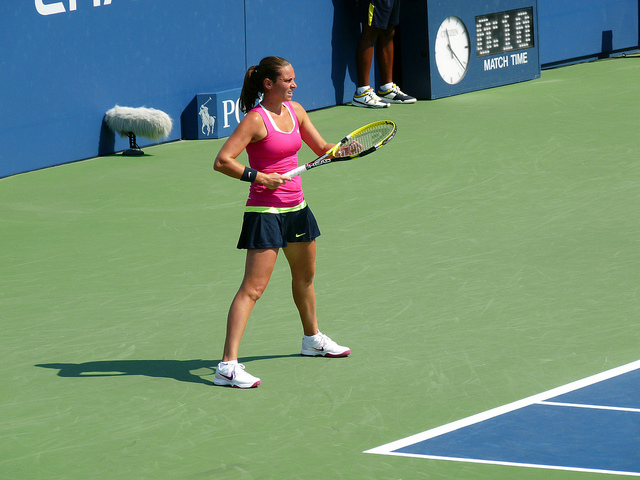<image>Why is the young man in green shirt and white shorts have his back foot off the ground? There is no young man in a green shirt and white shorts with his foot off the ground in the image. Why is the young man in green shirt and white shorts have his back foot off the ground? I don't know why the young man in green shirt and white shorts has his back foot off the ground. There may not be a man in the image. 